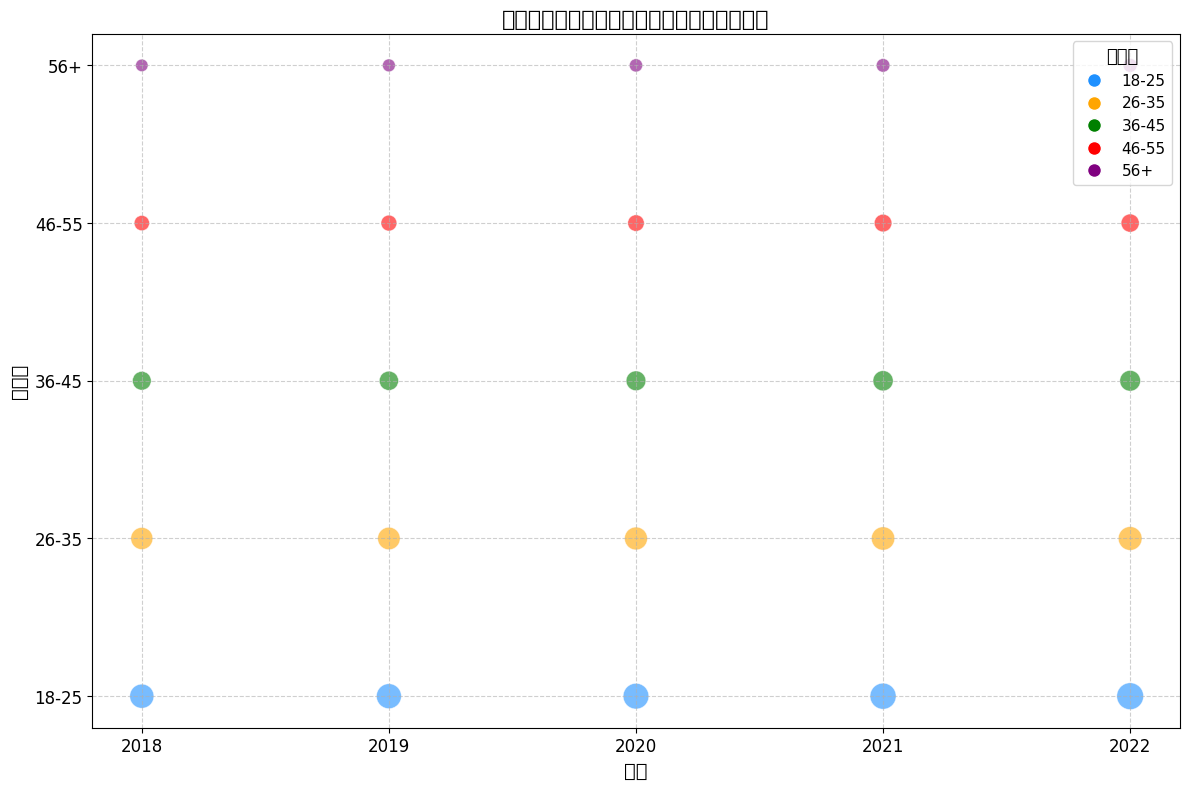哪个年龄段在2022年的销售数量最多？ 查看2022年的数据，发现18-25岁年龄段的销售数量最多，是3700
Answer: 18-25岁 哪个年份56岁以上读者的销售数量最高？ 查看每一年的数据，发现56岁以上读者在2022年的销售数量最高，是1000
Answer: 2022 从2018年到2022年，哪个年龄段的销售数量增加最多？ 对比2018年和2022年的数据，发现18-25岁年龄段的销售数量从3000增加到3700，增加了700，是增长最多的年龄段
Answer: 18-25岁 2021年和2022年的26-35岁年龄段的销售数量差了多少？ 查看2021年和2022年的数据，26-35岁年龄段的销售数量分别是2800和2900，两者相差2900-2800=100
Answer: 100 哪个年龄段的销售数量在这五年中最稳定？ 查看各年龄段的销售数量变化，发现56岁以上年龄段的销售数量变化最小，分别是800, 850, 900, 950, 1000，比较稳定
Answer: 56岁以上 2020年的哪两个年龄段的销售数量最为接近？ 查看2020年的数据，发现46-55岁和56岁以上两个年龄段的销售数量分别是1400和900，差值500，比其他年龄段更接近
Answer: 46-55岁和56岁以上 哪个年份18-25岁年龄段的销售数量最多？ 查看每一年的18-25岁年龄段的销售数量，发现2022年最多，是3700
Answer: 2022 哪个年龄段的泡泡大小变化最明显？ 查看每个年龄段的泡泡大小变化，发现18-25岁年龄段的泡泡大小变化最大，从30增加到37
Answer: 18-25岁 2022年和2020年的36-45岁年龄段的销售数量总和是多少？ 加上2022年和2020年的36-45岁年龄段的销售数量，分别是2200和2000，总和是2200+2000=4200
Answer: 4200 